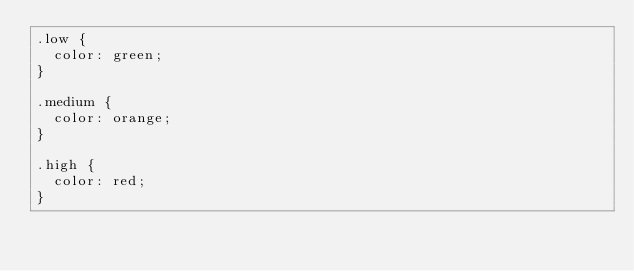<code> <loc_0><loc_0><loc_500><loc_500><_CSS_>.low {
  color: green;
}

.medium {
  color: orange;
}

.high {
  color: red;
}
</code> 